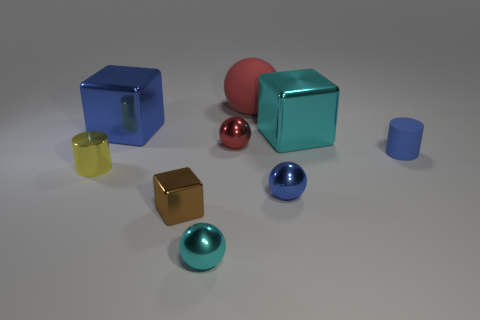What number of other things are there of the same shape as the large cyan metal object?
Your answer should be compact. 2. There is a cyan object that is in front of the tiny metal sphere that is behind the tiny yellow cylinder; what size is it?
Provide a short and direct response. Small. Are there any large purple objects?
Offer a terse response. No. What number of shiny spheres are behind the small blue thing to the left of the tiny rubber cylinder?
Ensure brevity in your answer.  1. What is the shape of the small thing that is left of the blue block?
Offer a terse response. Cylinder. There is a tiny cylinder that is to the right of the cyan metal thing to the left of the cyan thing that is right of the tiny red object; what is it made of?
Make the answer very short. Rubber. What number of other things are the same size as the red matte thing?
Your answer should be compact. 2. There is another object that is the same shape as the small yellow object; what is it made of?
Ensure brevity in your answer.  Rubber. What is the color of the shiny cylinder?
Offer a terse response. Yellow. There is a tiny shiny thing that is to the left of the large metal object on the left side of the red matte sphere; what color is it?
Provide a short and direct response. Yellow. 